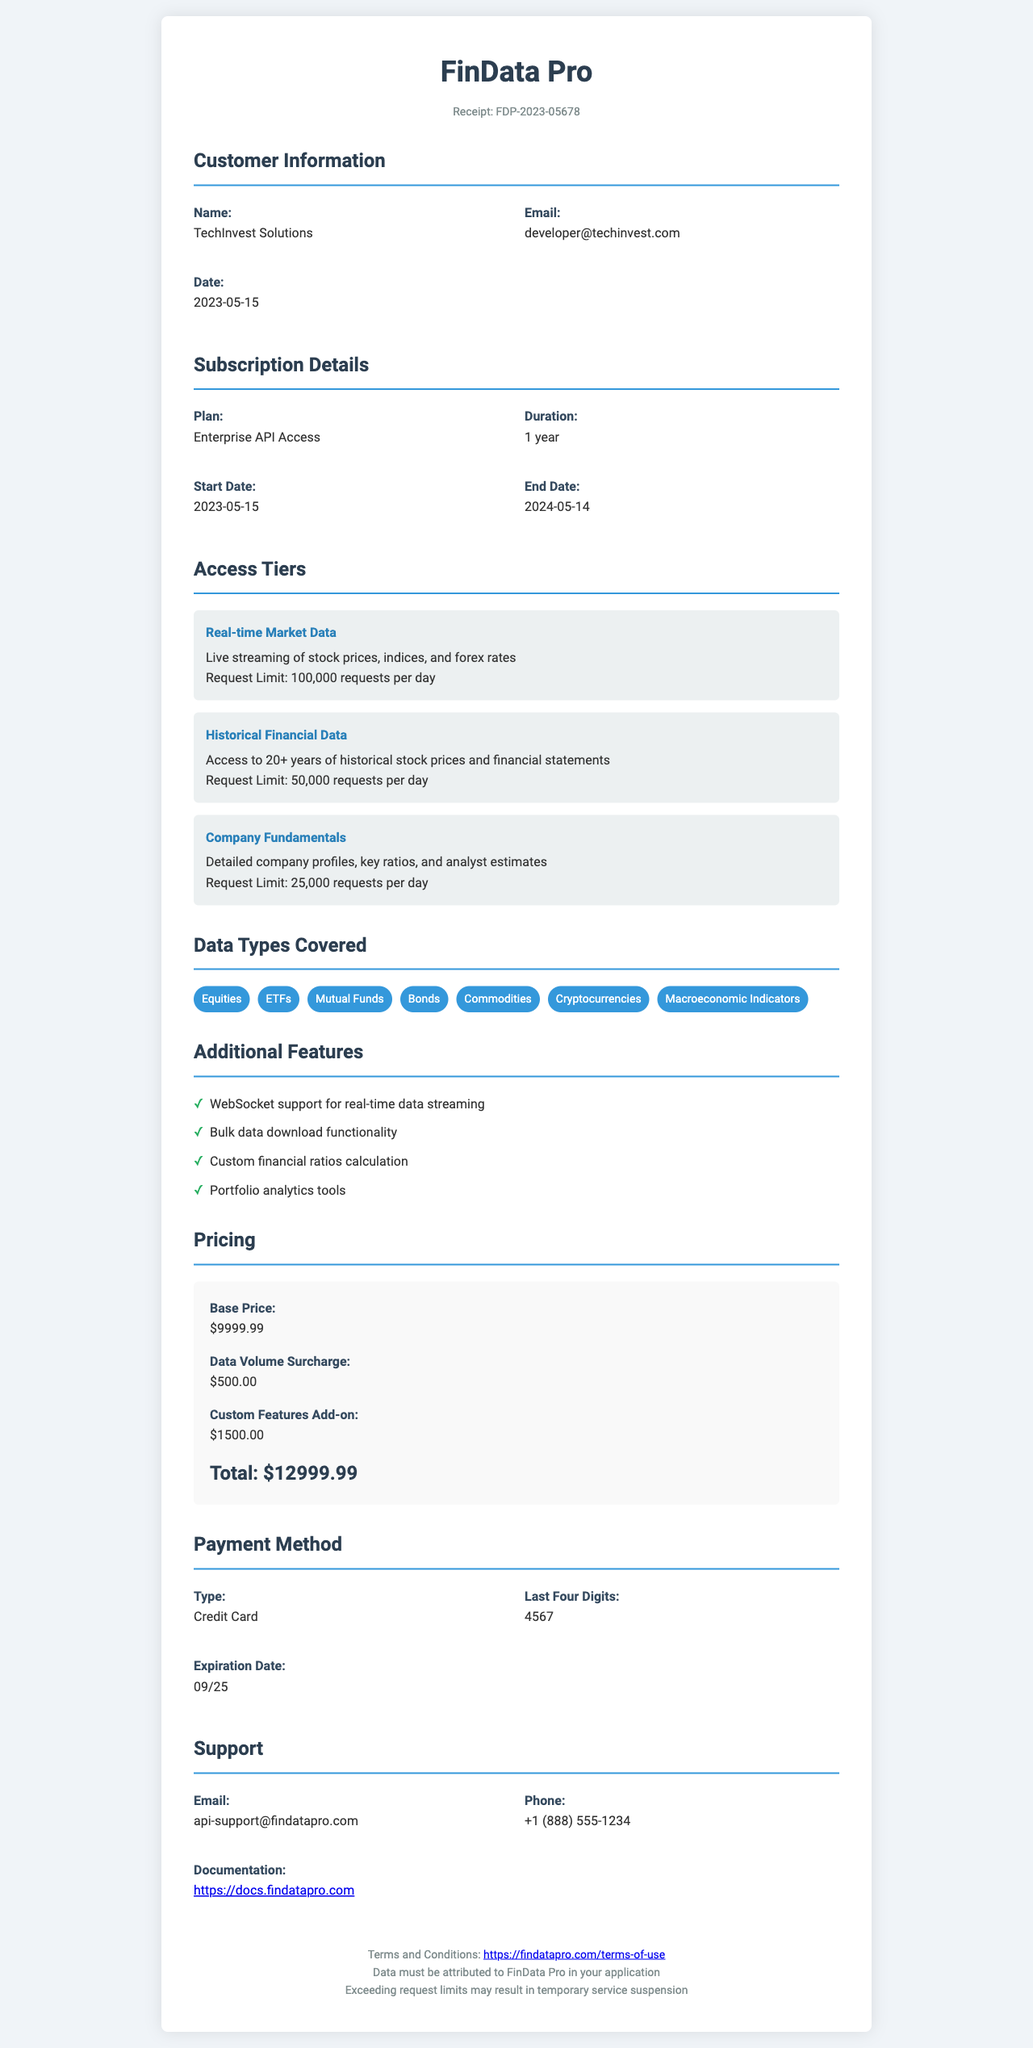what is the company name? The company name is listed at the top of the receipt.
Answer: FinData Pro what is the subscription plan name? The subscription plan name is mentioned in the subscription details section.
Answer: Enterprise API Access what is the total amount paid? The total amount is shown in the pricing section at the end of the document.
Answer: $12999.99 when does the subscription end? The end date of the subscription is provided in the subscription details section of the receipt.
Answer: 2024-05-14 how many requests can be made for real-time market data? The request limit for real-time market data is stated under the access tiers section.
Answer: 100,000 requests per day what additional feature provides support for real-time data streaming? The additional features section lists various functionalities, including that which supports real-time data.
Answer: WebSocket support for real-time data streaming what is the email for support? The support email is provided in the support section of the document.
Answer: api-support@findatapro.com how many years is the subscription duration? The subscription duration is indicated in the subscription details section.
Answer: 1 year what must be done with the data in terms of attribution? The document includes terms regarding data usage and attribution in the terms and conditions section.
Answer: Data must be attributed to FinData Pro in your application 